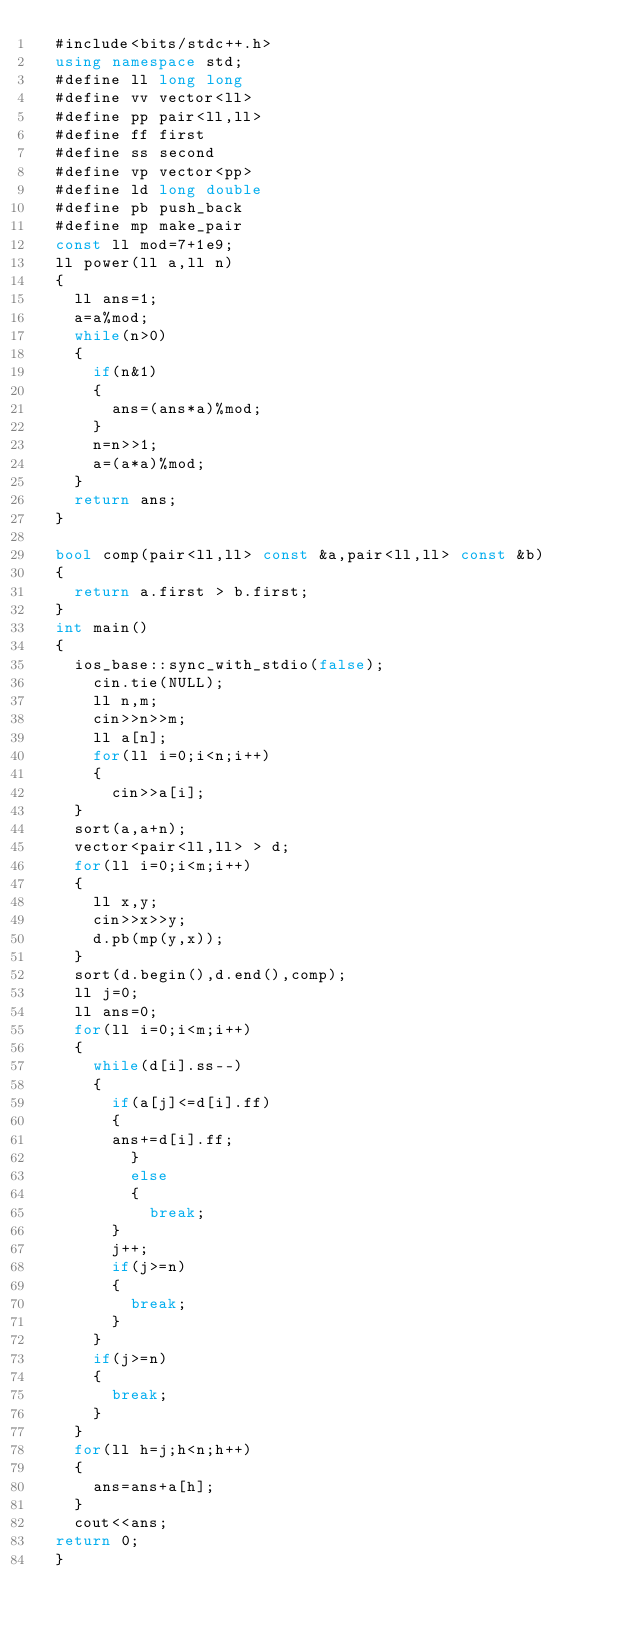Convert code to text. <code><loc_0><loc_0><loc_500><loc_500><_C++_>	#include<bits/stdc++.h>
	using namespace std;
	#define ll long long
	#define vv vector<ll>
	#define pp pair<ll,ll>
	#define ff first
	#define ss second
	#define vp vector<pp>
	#define ld long double
	#define pb push_back
	#define mp make_pair
	const ll mod=7+1e9;
	ll power(ll a,ll n)
	{
		ll ans=1;
		a=a%mod;
		while(n>0)
		{
			if(n&1)
			{
				ans=(ans*a)%mod;
			}
			n=n>>1;
			a=(a*a)%mod;
		}
		return ans;
	}
	
	bool comp(pair<ll,ll> const &a,pair<ll,ll> const &b)
	{
		return a.first > b.first;
	}
	int main() 
	{
		ios_base::sync_with_stdio(false);
	    cin.tie(NULL);
	    ll n,m;
	    cin>>n>>m;
	    ll a[n];
	    for(ll i=0;i<n;i++)
	    {
	    	cin>>a[i];
		}
		sort(a,a+n);
		vector<pair<ll,ll> > d;
		for(ll i=0;i<m;i++)
		{
			ll x,y;
			cin>>x>>y;
			d.pb(mp(y,x));
		}
		sort(d.begin(),d.end(),comp);
		ll j=0;
		ll ans=0;
		for(ll i=0;i<m;i++)
		{
			while(d[i].ss--)
			{
				if(a[j]<=d[i].ff)
				{
				ans+=d[i].ff;
			    }
			    else
			    {
			    	break;
				}
				j++;
				if(j>=n)
				{
					break;
				}
			}
			if(j>=n)
			{
				break;
			}
		}
		for(ll h=j;h<n;h++)
		{
			ans=ans+a[h];
		}
		cout<<ans;
	return 0;
	}</code> 